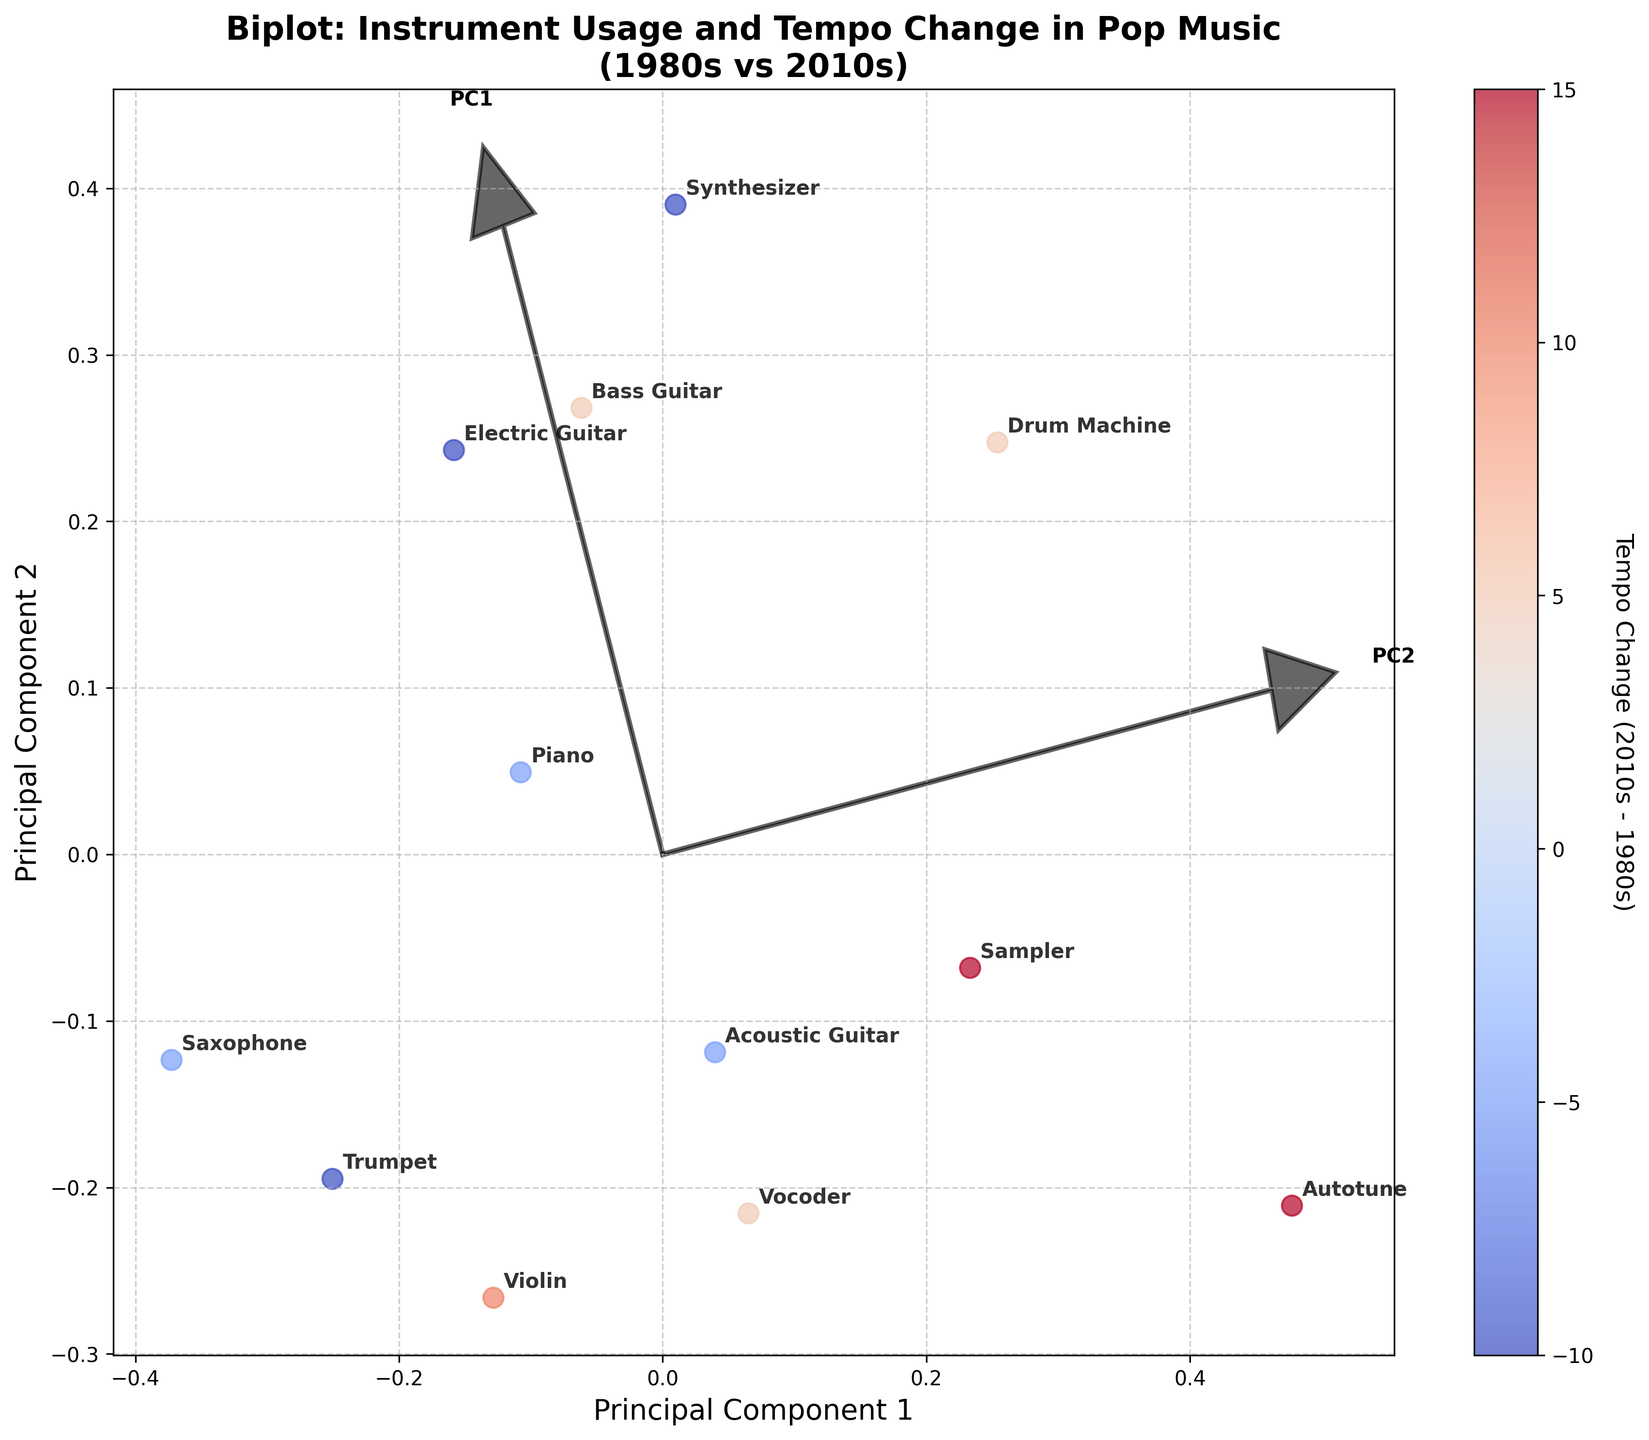Which instrument shows the highest tempo increase from the 1980s to the 2010s according to the color bar? In the biplot, the color bar indicates tempo change from the 1980s to the 2010s. The instrument with the deepest shade of warm color (darker red) represents the highest tempo increase.
Answer: Sampler Which instrument has the lowest usage in the 2010s according to the plot? Observe the position of data points along Principal Component 1 and identify the instrument label closest to the lowest end of the axis.
Answer: Saxophone How does the position of the Drum Machine compare to the Vocoder in terms of both principal components? Locate the positions of "Drum Machine" and "Vocoder" on the plot and compare their coordinates on both the horizontal and vertical axes.
Answer: Drum Machine is higher in PC2 and slightly higher in PC1 compared to the Vocoder Which principal component seems to differentiate the instruments based on usage between decades better? Analyze the direction and magnitude of principal component vectors. The lengthier and more scattered PC suggests better differentiation.
Answer: PC1 How many instruments appear in the plot? Count the number of unique data points or labels present in the plot.
Answer: 12 